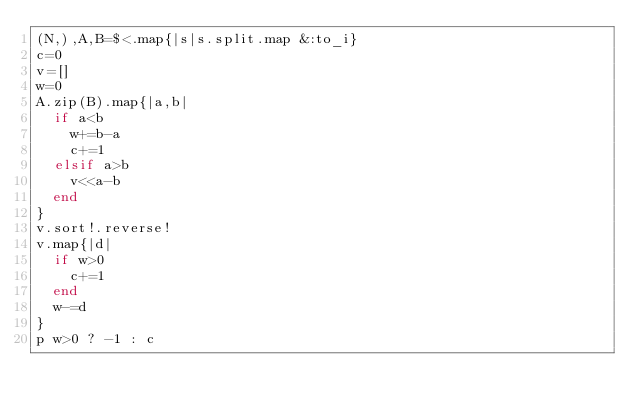Convert code to text. <code><loc_0><loc_0><loc_500><loc_500><_Ruby_>(N,),A,B=$<.map{|s|s.split.map &:to_i}
c=0
v=[]
w=0
A.zip(B).map{|a,b|
  if a<b
    w+=b-a
    c+=1
  elsif a>b
    v<<a-b
  end
}
v.sort!.reverse!
v.map{|d|
  if w>0
    c+=1
  end
  w-=d
}
p w>0 ? -1 : c</code> 